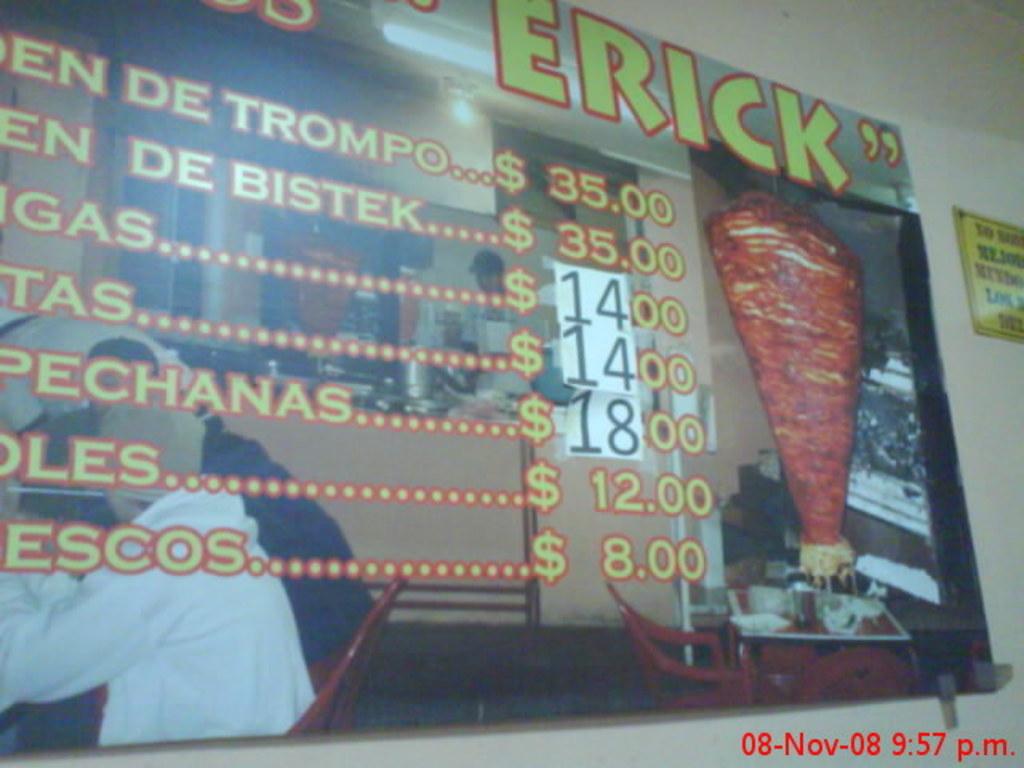What is the first price listed?
Provide a succinct answer. $35.00. 